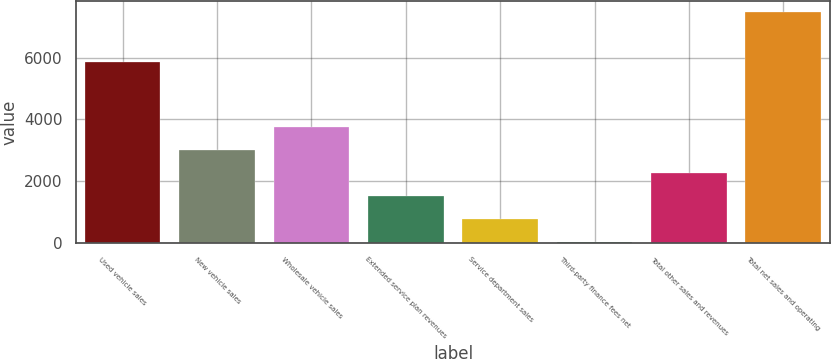Convert chart to OTSL. <chart><loc_0><loc_0><loc_500><loc_500><bar_chart><fcel>Used vehicle sales<fcel>New vehicle sales<fcel>Wholesale vehicle sales<fcel>Extended service plan revenues<fcel>Service department sales<fcel>Third-party finance fees net<fcel>Total other sales and revenues<fcel>Total net sales and operating<nl><fcel>5872.8<fcel>3000.86<fcel>3745<fcel>1512.58<fcel>768.44<fcel>24.3<fcel>2256.72<fcel>7465.7<nl></chart> 